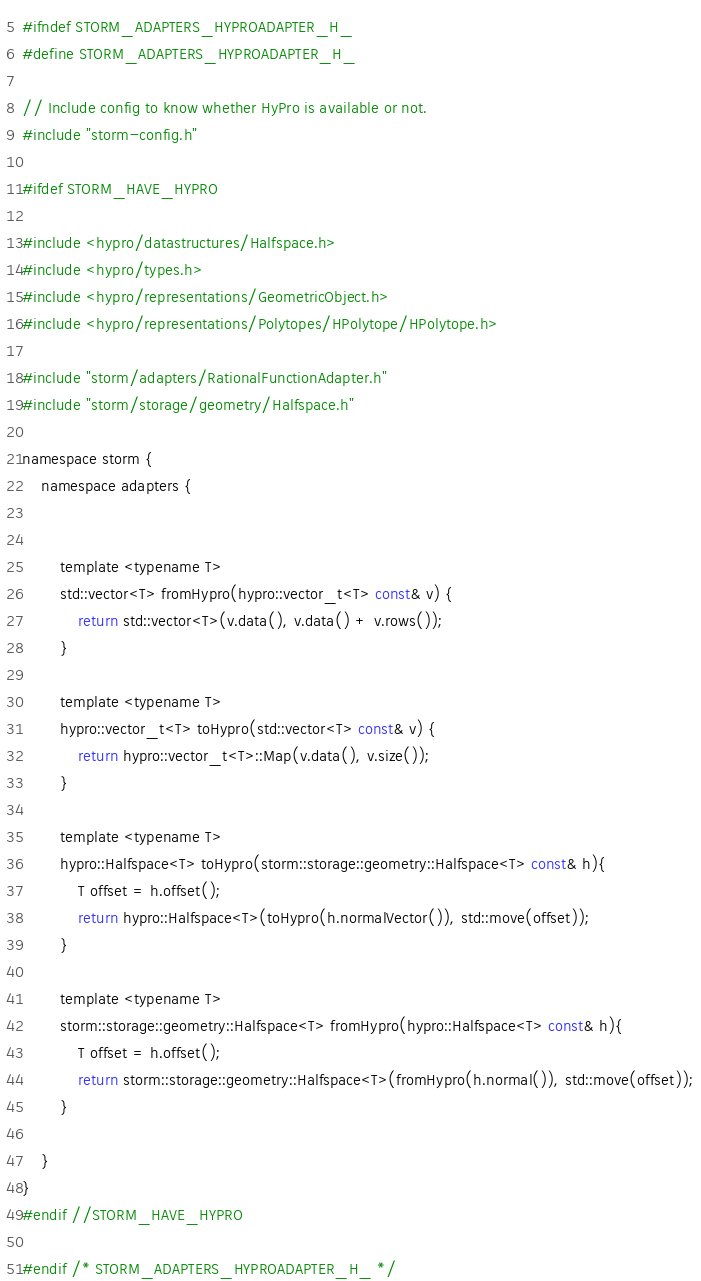<code> <loc_0><loc_0><loc_500><loc_500><_C_>#ifndef STORM_ADAPTERS_HYPROADAPTER_H_
#define STORM_ADAPTERS_HYPROADAPTER_H_

// Include config to know whether HyPro is available or not.
#include "storm-config.h"

#ifdef STORM_HAVE_HYPRO

#include <hypro/datastructures/Halfspace.h>
#include <hypro/types.h>
#include <hypro/representations/GeometricObject.h>
#include <hypro/representations/Polytopes/HPolytope/HPolytope.h>

#include "storm/adapters/RationalFunctionAdapter.h"
#include "storm/storage/geometry/Halfspace.h"

namespace storm {
    namespace adapters {
        
            
        template <typename T>
        std::vector<T> fromHypro(hypro::vector_t<T> const& v) {
            return std::vector<T>(v.data(), v.data() + v.rows());
        }
            
        template <typename T>
        hypro::vector_t<T> toHypro(std::vector<T> const& v) {
            return hypro::vector_t<T>::Map(v.data(), v.size());
        }
        
        template <typename T>
        hypro::Halfspace<T> toHypro(storm::storage::geometry::Halfspace<T> const& h){
            T offset = h.offset();
            return hypro::Halfspace<T>(toHypro(h.normalVector()), std::move(offset));
        }
        
        template <typename T>
        storm::storage::geometry::Halfspace<T> fromHypro(hypro::Halfspace<T> const& h){
            T offset = h.offset();
            return storm::storage::geometry::Halfspace<T>(fromHypro(h.normal()), std::move(offset));
        }
        
    }
}
#endif //STORM_HAVE_HYPRO
        
#endif /* STORM_ADAPTERS_HYPROADAPTER_H_ */
</code> 